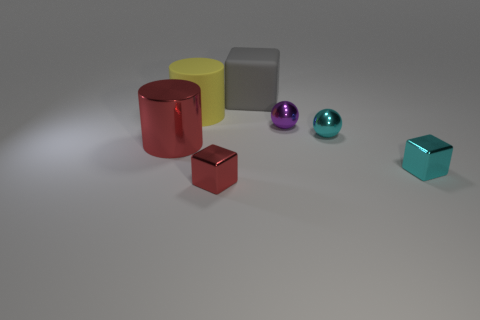There is a cyan shiny object to the left of the cyan block; is it the same size as the small red metal block?
Your answer should be compact. Yes. Is there any other thing that is the same size as the red shiny cylinder?
Give a very brief answer. Yes. Is the number of matte blocks that are in front of the purple metallic object greater than the number of tiny red blocks that are on the right side of the small red metal block?
Your answer should be very brief. No. There is a ball that is in front of the tiny metal thing behind the metallic ball that is right of the purple ball; what color is it?
Your answer should be compact. Cyan. Is the color of the tiny cube that is in front of the cyan block the same as the rubber cube?
Offer a very short reply. No. How many other things are the same color as the large rubber cylinder?
Provide a succinct answer. 0. How many objects are either red metal cubes or small shiny blocks?
Keep it short and to the point. 2. How many things are red cylinders or things that are behind the tiny red object?
Give a very brief answer. 6. Do the gray cube and the tiny purple object have the same material?
Offer a very short reply. No. What number of other objects are the same material as the yellow cylinder?
Your response must be concise. 1. 